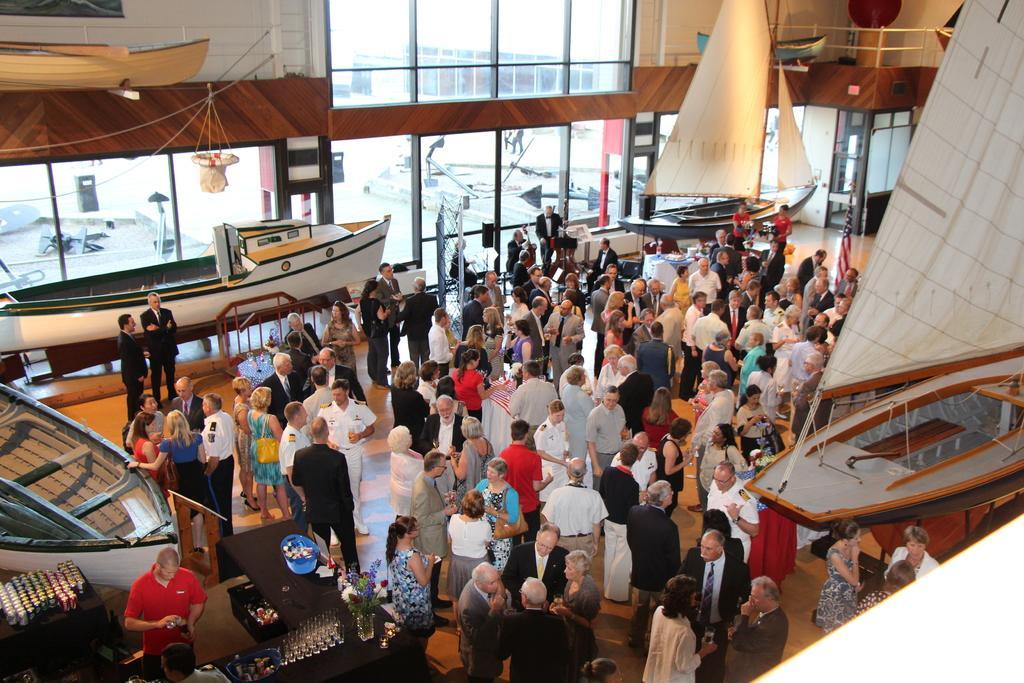In one or two sentences, can you explain what this image depicts? In this image I can see crowd of people visible on floor ,at the bottom I can see a table , on table I can see flower boo key and basket and glasses and person visible in front of table and I can see another table in the bottom left , on table i can see glasses and I can see boats visible on the floor and I can see display window visible in the middle. 